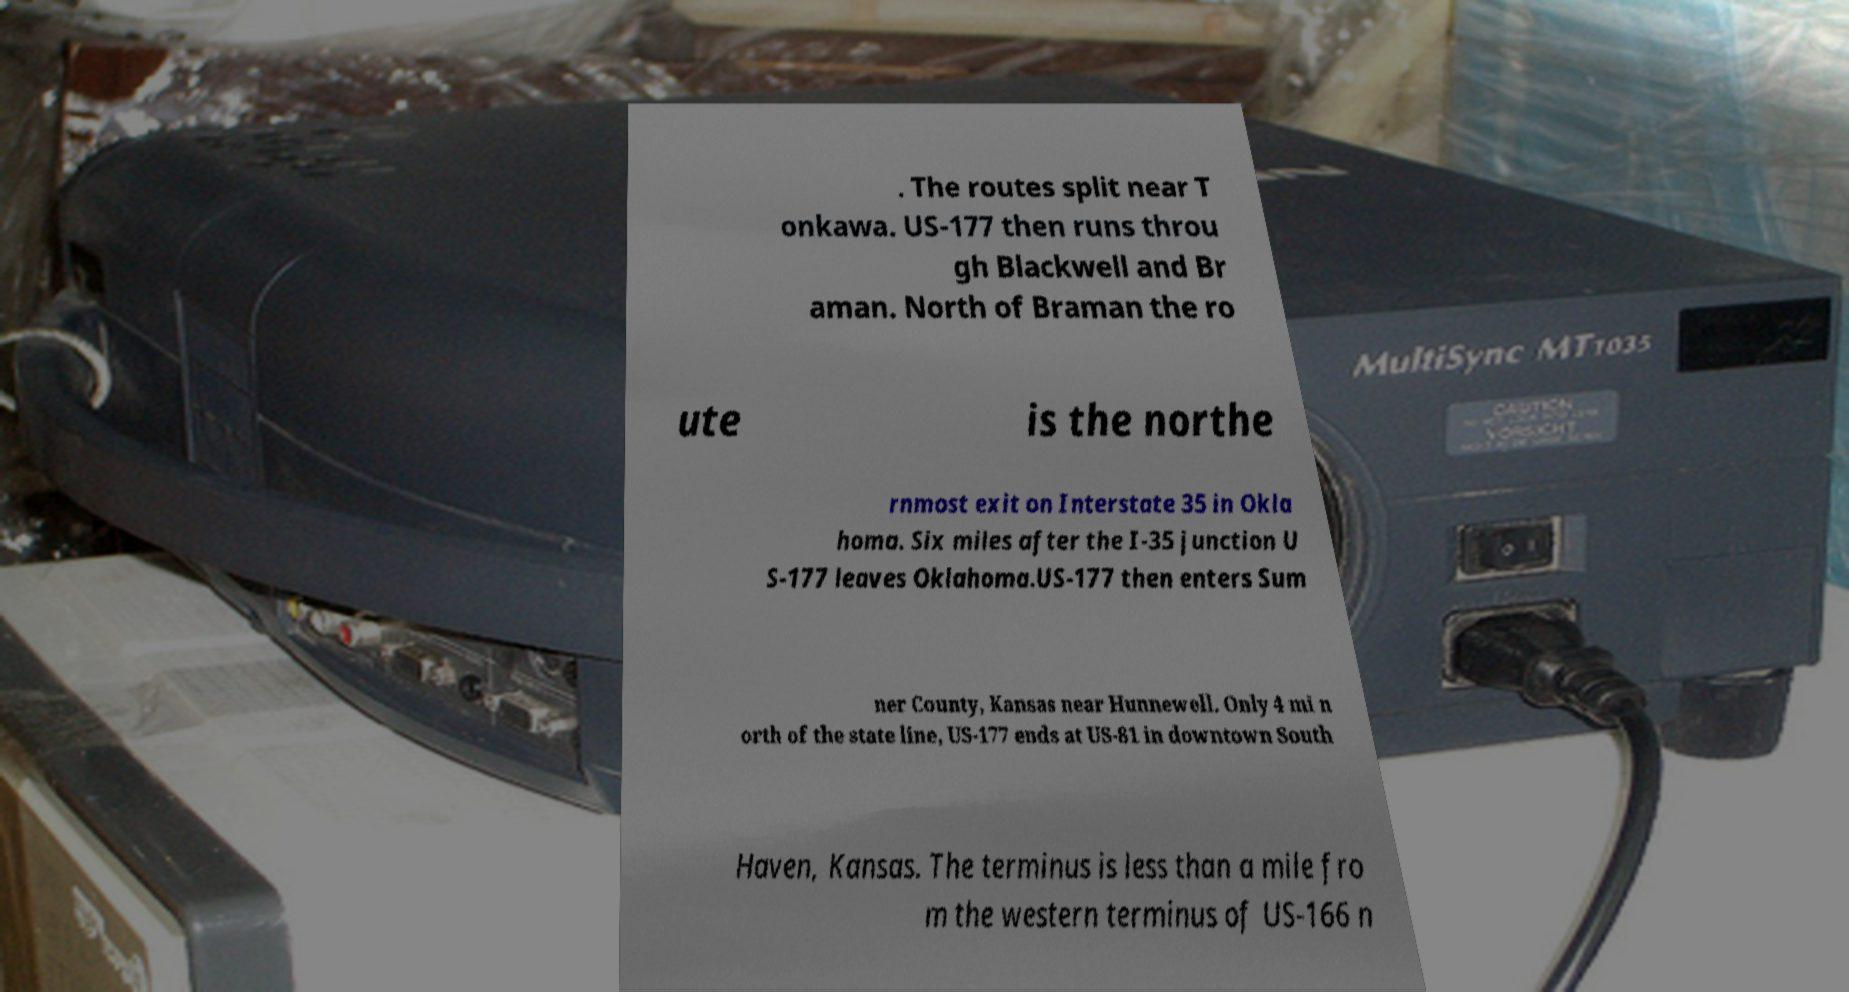Can you accurately transcribe the text from the provided image for me? . The routes split near T onkawa. US-177 then runs throu gh Blackwell and Br aman. North of Braman the ro ute is the northe rnmost exit on Interstate 35 in Okla homa. Six miles after the I-35 junction U S-177 leaves Oklahoma.US-177 then enters Sum ner County, Kansas near Hunnewell. Only 4 mi n orth of the state line, US-177 ends at US-81 in downtown South Haven, Kansas. The terminus is less than a mile fro m the western terminus of US-166 n 